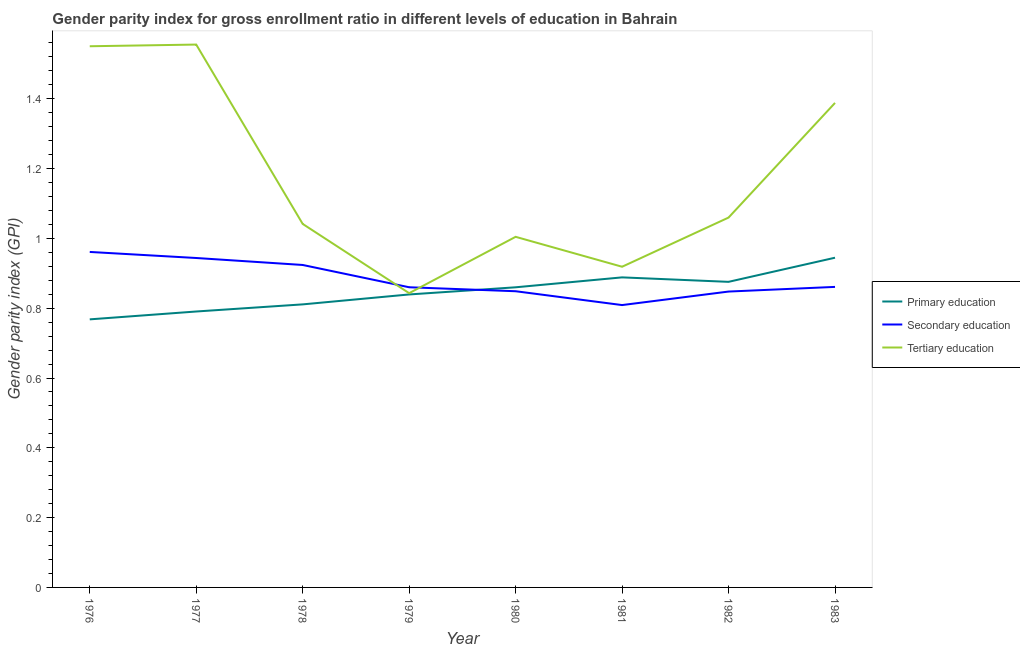How many different coloured lines are there?
Offer a terse response. 3. What is the gender parity index in secondary education in 1979?
Give a very brief answer. 0.86. Across all years, what is the maximum gender parity index in primary education?
Provide a short and direct response. 0.94. Across all years, what is the minimum gender parity index in primary education?
Offer a very short reply. 0.77. In which year was the gender parity index in primary education minimum?
Your response must be concise. 1976. What is the total gender parity index in primary education in the graph?
Provide a short and direct response. 6.78. What is the difference between the gender parity index in secondary education in 1978 and that in 1983?
Keep it short and to the point. 0.06. What is the difference between the gender parity index in primary education in 1980 and the gender parity index in tertiary education in 1978?
Your answer should be compact. -0.18. What is the average gender parity index in secondary education per year?
Make the answer very short. 0.88. In the year 1978, what is the difference between the gender parity index in secondary education and gender parity index in primary education?
Make the answer very short. 0.11. What is the ratio of the gender parity index in primary education in 1977 to that in 1982?
Offer a terse response. 0.9. Is the gender parity index in tertiary education in 1978 less than that in 1983?
Make the answer very short. Yes. What is the difference between the highest and the second highest gender parity index in secondary education?
Give a very brief answer. 0.02. What is the difference between the highest and the lowest gender parity index in primary education?
Make the answer very short. 0.18. In how many years, is the gender parity index in tertiary education greater than the average gender parity index in tertiary education taken over all years?
Keep it short and to the point. 3. How many lines are there?
Your answer should be very brief. 3. What is the difference between two consecutive major ticks on the Y-axis?
Your answer should be compact. 0.2. Does the graph contain any zero values?
Offer a very short reply. No. How are the legend labels stacked?
Your answer should be very brief. Vertical. What is the title of the graph?
Offer a terse response. Gender parity index for gross enrollment ratio in different levels of education in Bahrain. Does "Grants" appear as one of the legend labels in the graph?
Your answer should be very brief. No. What is the label or title of the X-axis?
Make the answer very short. Year. What is the label or title of the Y-axis?
Ensure brevity in your answer.  Gender parity index (GPI). What is the Gender parity index (GPI) in Primary education in 1976?
Your answer should be very brief. 0.77. What is the Gender parity index (GPI) of Secondary education in 1976?
Make the answer very short. 0.96. What is the Gender parity index (GPI) of Tertiary education in 1976?
Keep it short and to the point. 1.55. What is the Gender parity index (GPI) in Primary education in 1977?
Your response must be concise. 0.79. What is the Gender parity index (GPI) in Secondary education in 1977?
Offer a very short reply. 0.94. What is the Gender parity index (GPI) in Tertiary education in 1977?
Offer a very short reply. 1.56. What is the Gender parity index (GPI) in Primary education in 1978?
Ensure brevity in your answer.  0.81. What is the Gender parity index (GPI) of Secondary education in 1978?
Give a very brief answer. 0.92. What is the Gender parity index (GPI) in Tertiary education in 1978?
Your answer should be compact. 1.04. What is the Gender parity index (GPI) in Primary education in 1979?
Give a very brief answer. 0.84. What is the Gender parity index (GPI) of Secondary education in 1979?
Your answer should be compact. 0.86. What is the Gender parity index (GPI) in Tertiary education in 1979?
Make the answer very short. 0.84. What is the Gender parity index (GPI) in Primary education in 1980?
Offer a very short reply. 0.86. What is the Gender parity index (GPI) in Secondary education in 1980?
Offer a very short reply. 0.85. What is the Gender parity index (GPI) of Tertiary education in 1980?
Your answer should be very brief. 1. What is the Gender parity index (GPI) in Primary education in 1981?
Offer a terse response. 0.89. What is the Gender parity index (GPI) in Secondary education in 1981?
Your answer should be compact. 0.81. What is the Gender parity index (GPI) in Tertiary education in 1981?
Your answer should be compact. 0.92. What is the Gender parity index (GPI) of Primary education in 1982?
Provide a succinct answer. 0.88. What is the Gender parity index (GPI) of Secondary education in 1982?
Make the answer very short. 0.85. What is the Gender parity index (GPI) in Tertiary education in 1982?
Your response must be concise. 1.06. What is the Gender parity index (GPI) in Primary education in 1983?
Your answer should be very brief. 0.94. What is the Gender parity index (GPI) of Secondary education in 1983?
Make the answer very short. 0.86. What is the Gender parity index (GPI) in Tertiary education in 1983?
Ensure brevity in your answer.  1.39. Across all years, what is the maximum Gender parity index (GPI) of Primary education?
Keep it short and to the point. 0.94. Across all years, what is the maximum Gender parity index (GPI) of Secondary education?
Your answer should be compact. 0.96. Across all years, what is the maximum Gender parity index (GPI) in Tertiary education?
Offer a very short reply. 1.56. Across all years, what is the minimum Gender parity index (GPI) of Primary education?
Keep it short and to the point. 0.77. Across all years, what is the minimum Gender parity index (GPI) of Secondary education?
Offer a terse response. 0.81. Across all years, what is the minimum Gender parity index (GPI) in Tertiary education?
Provide a succinct answer. 0.84. What is the total Gender parity index (GPI) in Primary education in the graph?
Provide a succinct answer. 6.78. What is the total Gender parity index (GPI) of Secondary education in the graph?
Your answer should be very brief. 7.06. What is the total Gender parity index (GPI) of Tertiary education in the graph?
Offer a very short reply. 9.36. What is the difference between the Gender parity index (GPI) in Primary education in 1976 and that in 1977?
Make the answer very short. -0.02. What is the difference between the Gender parity index (GPI) of Secondary education in 1976 and that in 1977?
Ensure brevity in your answer.  0.02. What is the difference between the Gender parity index (GPI) in Tertiary education in 1976 and that in 1977?
Provide a succinct answer. -0. What is the difference between the Gender parity index (GPI) of Primary education in 1976 and that in 1978?
Provide a short and direct response. -0.04. What is the difference between the Gender parity index (GPI) in Secondary education in 1976 and that in 1978?
Ensure brevity in your answer.  0.04. What is the difference between the Gender parity index (GPI) in Tertiary education in 1976 and that in 1978?
Offer a very short reply. 0.51. What is the difference between the Gender parity index (GPI) of Primary education in 1976 and that in 1979?
Make the answer very short. -0.07. What is the difference between the Gender parity index (GPI) in Secondary education in 1976 and that in 1979?
Keep it short and to the point. 0.1. What is the difference between the Gender parity index (GPI) of Tertiary education in 1976 and that in 1979?
Your answer should be compact. 0.71. What is the difference between the Gender parity index (GPI) in Primary education in 1976 and that in 1980?
Make the answer very short. -0.09. What is the difference between the Gender parity index (GPI) in Secondary education in 1976 and that in 1980?
Make the answer very short. 0.11. What is the difference between the Gender parity index (GPI) of Tertiary education in 1976 and that in 1980?
Keep it short and to the point. 0.55. What is the difference between the Gender parity index (GPI) in Primary education in 1976 and that in 1981?
Your answer should be very brief. -0.12. What is the difference between the Gender parity index (GPI) of Secondary education in 1976 and that in 1981?
Your answer should be compact. 0.15. What is the difference between the Gender parity index (GPI) in Tertiary education in 1976 and that in 1981?
Your answer should be very brief. 0.63. What is the difference between the Gender parity index (GPI) of Primary education in 1976 and that in 1982?
Your response must be concise. -0.11. What is the difference between the Gender parity index (GPI) of Secondary education in 1976 and that in 1982?
Give a very brief answer. 0.11. What is the difference between the Gender parity index (GPI) in Tertiary education in 1976 and that in 1982?
Give a very brief answer. 0.49. What is the difference between the Gender parity index (GPI) in Primary education in 1976 and that in 1983?
Ensure brevity in your answer.  -0.18. What is the difference between the Gender parity index (GPI) of Secondary education in 1976 and that in 1983?
Provide a short and direct response. 0.1. What is the difference between the Gender parity index (GPI) of Tertiary education in 1976 and that in 1983?
Ensure brevity in your answer.  0.16. What is the difference between the Gender parity index (GPI) of Primary education in 1977 and that in 1978?
Give a very brief answer. -0.02. What is the difference between the Gender parity index (GPI) of Tertiary education in 1977 and that in 1978?
Offer a very short reply. 0.51. What is the difference between the Gender parity index (GPI) of Primary education in 1977 and that in 1979?
Make the answer very short. -0.05. What is the difference between the Gender parity index (GPI) of Secondary education in 1977 and that in 1979?
Your answer should be compact. 0.08. What is the difference between the Gender parity index (GPI) of Tertiary education in 1977 and that in 1979?
Offer a terse response. 0.71. What is the difference between the Gender parity index (GPI) in Primary education in 1977 and that in 1980?
Make the answer very short. -0.07. What is the difference between the Gender parity index (GPI) in Secondary education in 1977 and that in 1980?
Make the answer very short. 0.1. What is the difference between the Gender parity index (GPI) of Tertiary education in 1977 and that in 1980?
Ensure brevity in your answer.  0.55. What is the difference between the Gender parity index (GPI) of Primary education in 1977 and that in 1981?
Offer a very short reply. -0.1. What is the difference between the Gender parity index (GPI) of Secondary education in 1977 and that in 1981?
Offer a terse response. 0.13. What is the difference between the Gender parity index (GPI) of Tertiary education in 1977 and that in 1981?
Ensure brevity in your answer.  0.64. What is the difference between the Gender parity index (GPI) in Primary education in 1977 and that in 1982?
Your answer should be very brief. -0.09. What is the difference between the Gender parity index (GPI) in Secondary education in 1977 and that in 1982?
Ensure brevity in your answer.  0.1. What is the difference between the Gender parity index (GPI) in Tertiary education in 1977 and that in 1982?
Provide a short and direct response. 0.5. What is the difference between the Gender parity index (GPI) in Primary education in 1977 and that in 1983?
Make the answer very short. -0.15. What is the difference between the Gender parity index (GPI) of Secondary education in 1977 and that in 1983?
Make the answer very short. 0.08. What is the difference between the Gender parity index (GPI) of Tertiary education in 1977 and that in 1983?
Keep it short and to the point. 0.17. What is the difference between the Gender parity index (GPI) in Primary education in 1978 and that in 1979?
Your answer should be very brief. -0.03. What is the difference between the Gender parity index (GPI) in Secondary education in 1978 and that in 1979?
Ensure brevity in your answer.  0.06. What is the difference between the Gender parity index (GPI) in Tertiary education in 1978 and that in 1979?
Make the answer very short. 0.2. What is the difference between the Gender parity index (GPI) of Primary education in 1978 and that in 1980?
Your answer should be very brief. -0.05. What is the difference between the Gender parity index (GPI) in Secondary education in 1978 and that in 1980?
Offer a terse response. 0.08. What is the difference between the Gender parity index (GPI) in Tertiary education in 1978 and that in 1980?
Offer a very short reply. 0.04. What is the difference between the Gender parity index (GPI) of Primary education in 1978 and that in 1981?
Offer a terse response. -0.08. What is the difference between the Gender parity index (GPI) in Secondary education in 1978 and that in 1981?
Give a very brief answer. 0.11. What is the difference between the Gender parity index (GPI) in Tertiary education in 1978 and that in 1981?
Offer a very short reply. 0.12. What is the difference between the Gender parity index (GPI) in Primary education in 1978 and that in 1982?
Your response must be concise. -0.06. What is the difference between the Gender parity index (GPI) of Secondary education in 1978 and that in 1982?
Provide a succinct answer. 0.08. What is the difference between the Gender parity index (GPI) in Tertiary education in 1978 and that in 1982?
Provide a succinct answer. -0.02. What is the difference between the Gender parity index (GPI) of Primary education in 1978 and that in 1983?
Make the answer very short. -0.13. What is the difference between the Gender parity index (GPI) in Secondary education in 1978 and that in 1983?
Give a very brief answer. 0.06. What is the difference between the Gender parity index (GPI) in Tertiary education in 1978 and that in 1983?
Your response must be concise. -0.35. What is the difference between the Gender parity index (GPI) of Primary education in 1979 and that in 1980?
Offer a terse response. -0.02. What is the difference between the Gender parity index (GPI) of Secondary education in 1979 and that in 1980?
Provide a short and direct response. 0.01. What is the difference between the Gender parity index (GPI) of Tertiary education in 1979 and that in 1980?
Your answer should be compact. -0.16. What is the difference between the Gender parity index (GPI) of Primary education in 1979 and that in 1981?
Ensure brevity in your answer.  -0.05. What is the difference between the Gender parity index (GPI) of Secondary education in 1979 and that in 1981?
Ensure brevity in your answer.  0.05. What is the difference between the Gender parity index (GPI) in Tertiary education in 1979 and that in 1981?
Make the answer very short. -0.08. What is the difference between the Gender parity index (GPI) in Primary education in 1979 and that in 1982?
Provide a short and direct response. -0.04. What is the difference between the Gender parity index (GPI) of Secondary education in 1979 and that in 1982?
Ensure brevity in your answer.  0.01. What is the difference between the Gender parity index (GPI) in Tertiary education in 1979 and that in 1982?
Keep it short and to the point. -0.22. What is the difference between the Gender parity index (GPI) in Primary education in 1979 and that in 1983?
Offer a very short reply. -0.11. What is the difference between the Gender parity index (GPI) of Secondary education in 1979 and that in 1983?
Provide a short and direct response. -0. What is the difference between the Gender parity index (GPI) in Tertiary education in 1979 and that in 1983?
Keep it short and to the point. -0.55. What is the difference between the Gender parity index (GPI) in Primary education in 1980 and that in 1981?
Provide a succinct answer. -0.03. What is the difference between the Gender parity index (GPI) of Secondary education in 1980 and that in 1981?
Your answer should be compact. 0.04. What is the difference between the Gender parity index (GPI) in Tertiary education in 1980 and that in 1981?
Provide a short and direct response. 0.09. What is the difference between the Gender parity index (GPI) of Primary education in 1980 and that in 1982?
Your response must be concise. -0.02. What is the difference between the Gender parity index (GPI) in Secondary education in 1980 and that in 1982?
Ensure brevity in your answer.  0. What is the difference between the Gender parity index (GPI) of Tertiary education in 1980 and that in 1982?
Provide a short and direct response. -0.06. What is the difference between the Gender parity index (GPI) in Primary education in 1980 and that in 1983?
Your answer should be very brief. -0.08. What is the difference between the Gender parity index (GPI) of Secondary education in 1980 and that in 1983?
Offer a terse response. -0.01. What is the difference between the Gender parity index (GPI) in Tertiary education in 1980 and that in 1983?
Your answer should be compact. -0.38. What is the difference between the Gender parity index (GPI) in Primary education in 1981 and that in 1982?
Give a very brief answer. 0.01. What is the difference between the Gender parity index (GPI) in Secondary education in 1981 and that in 1982?
Give a very brief answer. -0.04. What is the difference between the Gender parity index (GPI) of Tertiary education in 1981 and that in 1982?
Your response must be concise. -0.14. What is the difference between the Gender parity index (GPI) of Primary education in 1981 and that in 1983?
Your response must be concise. -0.06. What is the difference between the Gender parity index (GPI) of Secondary education in 1981 and that in 1983?
Provide a short and direct response. -0.05. What is the difference between the Gender parity index (GPI) of Tertiary education in 1981 and that in 1983?
Offer a very short reply. -0.47. What is the difference between the Gender parity index (GPI) in Primary education in 1982 and that in 1983?
Your answer should be compact. -0.07. What is the difference between the Gender parity index (GPI) in Secondary education in 1982 and that in 1983?
Keep it short and to the point. -0.01. What is the difference between the Gender parity index (GPI) of Tertiary education in 1982 and that in 1983?
Make the answer very short. -0.33. What is the difference between the Gender parity index (GPI) in Primary education in 1976 and the Gender parity index (GPI) in Secondary education in 1977?
Provide a short and direct response. -0.18. What is the difference between the Gender parity index (GPI) of Primary education in 1976 and the Gender parity index (GPI) of Tertiary education in 1977?
Provide a short and direct response. -0.79. What is the difference between the Gender parity index (GPI) of Secondary education in 1976 and the Gender parity index (GPI) of Tertiary education in 1977?
Give a very brief answer. -0.59. What is the difference between the Gender parity index (GPI) in Primary education in 1976 and the Gender parity index (GPI) in Secondary education in 1978?
Provide a succinct answer. -0.16. What is the difference between the Gender parity index (GPI) of Primary education in 1976 and the Gender parity index (GPI) of Tertiary education in 1978?
Provide a succinct answer. -0.27. What is the difference between the Gender parity index (GPI) of Secondary education in 1976 and the Gender parity index (GPI) of Tertiary education in 1978?
Offer a very short reply. -0.08. What is the difference between the Gender parity index (GPI) of Primary education in 1976 and the Gender parity index (GPI) of Secondary education in 1979?
Provide a succinct answer. -0.09. What is the difference between the Gender parity index (GPI) in Primary education in 1976 and the Gender parity index (GPI) in Tertiary education in 1979?
Keep it short and to the point. -0.07. What is the difference between the Gender parity index (GPI) of Secondary education in 1976 and the Gender parity index (GPI) of Tertiary education in 1979?
Your response must be concise. 0.12. What is the difference between the Gender parity index (GPI) of Primary education in 1976 and the Gender parity index (GPI) of Secondary education in 1980?
Offer a very short reply. -0.08. What is the difference between the Gender parity index (GPI) of Primary education in 1976 and the Gender parity index (GPI) of Tertiary education in 1980?
Provide a succinct answer. -0.24. What is the difference between the Gender parity index (GPI) of Secondary education in 1976 and the Gender parity index (GPI) of Tertiary education in 1980?
Your response must be concise. -0.04. What is the difference between the Gender parity index (GPI) in Primary education in 1976 and the Gender parity index (GPI) in Secondary education in 1981?
Your response must be concise. -0.04. What is the difference between the Gender parity index (GPI) of Primary education in 1976 and the Gender parity index (GPI) of Tertiary education in 1981?
Provide a short and direct response. -0.15. What is the difference between the Gender parity index (GPI) in Secondary education in 1976 and the Gender parity index (GPI) in Tertiary education in 1981?
Offer a terse response. 0.04. What is the difference between the Gender parity index (GPI) in Primary education in 1976 and the Gender parity index (GPI) in Secondary education in 1982?
Your answer should be very brief. -0.08. What is the difference between the Gender parity index (GPI) in Primary education in 1976 and the Gender parity index (GPI) in Tertiary education in 1982?
Provide a succinct answer. -0.29. What is the difference between the Gender parity index (GPI) in Secondary education in 1976 and the Gender parity index (GPI) in Tertiary education in 1982?
Your answer should be very brief. -0.1. What is the difference between the Gender parity index (GPI) of Primary education in 1976 and the Gender parity index (GPI) of Secondary education in 1983?
Your answer should be very brief. -0.09. What is the difference between the Gender parity index (GPI) in Primary education in 1976 and the Gender parity index (GPI) in Tertiary education in 1983?
Offer a very short reply. -0.62. What is the difference between the Gender parity index (GPI) in Secondary education in 1976 and the Gender parity index (GPI) in Tertiary education in 1983?
Your answer should be compact. -0.43. What is the difference between the Gender parity index (GPI) of Primary education in 1977 and the Gender parity index (GPI) of Secondary education in 1978?
Provide a succinct answer. -0.13. What is the difference between the Gender parity index (GPI) in Primary education in 1977 and the Gender parity index (GPI) in Tertiary education in 1978?
Provide a succinct answer. -0.25. What is the difference between the Gender parity index (GPI) of Secondary education in 1977 and the Gender parity index (GPI) of Tertiary education in 1978?
Provide a short and direct response. -0.1. What is the difference between the Gender parity index (GPI) in Primary education in 1977 and the Gender parity index (GPI) in Secondary education in 1979?
Your response must be concise. -0.07. What is the difference between the Gender parity index (GPI) in Primary education in 1977 and the Gender parity index (GPI) in Tertiary education in 1979?
Keep it short and to the point. -0.05. What is the difference between the Gender parity index (GPI) of Secondary education in 1977 and the Gender parity index (GPI) of Tertiary education in 1979?
Make the answer very short. 0.1. What is the difference between the Gender parity index (GPI) of Primary education in 1977 and the Gender parity index (GPI) of Secondary education in 1980?
Ensure brevity in your answer.  -0.06. What is the difference between the Gender parity index (GPI) of Primary education in 1977 and the Gender parity index (GPI) of Tertiary education in 1980?
Offer a terse response. -0.21. What is the difference between the Gender parity index (GPI) of Secondary education in 1977 and the Gender parity index (GPI) of Tertiary education in 1980?
Provide a succinct answer. -0.06. What is the difference between the Gender parity index (GPI) in Primary education in 1977 and the Gender parity index (GPI) in Secondary education in 1981?
Provide a succinct answer. -0.02. What is the difference between the Gender parity index (GPI) in Primary education in 1977 and the Gender parity index (GPI) in Tertiary education in 1981?
Provide a succinct answer. -0.13. What is the difference between the Gender parity index (GPI) in Secondary education in 1977 and the Gender parity index (GPI) in Tertiary education in 1981?
Give a very brief answer. 0.03. What is the difference between the Gender parity index (GPI) in Primary education in 1977 and the Gender parity index (GPI) in Secondary education in 1982?
Give a very brief answer. -0.06. What is the difference between the Gender parity index (GPI) in Primary education in 1977 and the Gender parity index (GPI) in Tertiary education in 1982?
Your answer should be very brief. -0.27. What is the difference between the Gender parity index (GPI) of Secondary education in 1977 and the Gender parity index (GPI) of Tertiary education in 1982?
Your response must be concise. -0.12. What is the difference between the Gender parity index (GPI) in Primary education in 1977 and the Gender parity index (GPI) in Secondary education in 1983?
Your answer should be compact. -0.07. What is the difference between the Gender parity index (GPI) in Primary education in 1977 and the Gender parity index (GPI) in Tertiary education in 1983?
Offer a terse response. -0.6. What is the difference between the Gender parity index (GPI) of Secondary education in 1977 and the Gender parity index (GPI) of Tertiary education in 1983?
Make the answer very short. -0.44. What is the difference between the Gender parity index (GPI) in Primary education in 1978 and the Gender parity index (GPI) in Secondary education in 1979?
Your answer should be compact. -0.05. What is the difference between the Gender parity index (GPI) in Primary education in 1978 and the Gender parity index (GPI) in Tertiary education in 1979?
Offer a very short reply. -0.03. What is the difference between the Gender parity index (GPI) of Secondary education in 1978 and the Gender parity index (GPI) of Tertiary education in 1979?
Your answer should be compact. 0.08. What is the difference between the Gender parity index (GPI) of Primary education in 1978 and the Gender parity index (GPI) of Secondary education in 1980?
Your response must be concise. -0.04. What is the difference between the Gender parity index (GPI) of Primary education in 1978 and the Gender parity index (GPI) of Tertiary education in 1980?
Your response must be concise. -0.19. What is the difference between the Gender parity index (GPI) of Secondary education in 1978 and the Gender parity index (GPI) of Tertiary education in 1980?
Make the answer very short. -0.08. What is the difference between the Gender parity index (GPI) in Primary education in 1978 and the Gender parity index (GPI) in Secondary education in 1981?
Keep it short and to the point. 0. What is the difference between the Gender parity index (GPI) in Primary education in 1978 and the Gender parity index (GPI) in Tertiary education in 1981?
Your response must be concise. -0.11. What is the difference between the Gender parity index (GPI) of Secondary education in 1978 and the Gender parity index (GPI) of Tertiary education in 1981?
Offer a very short reply. 0.01. What is the difference between the Gender parity index (GPI) of Primary education in 1978 and the Gender parity index (GPI) of Secondary education in 1982?
Your response must be concise. -0.04. What is the difference between the Gender parity index (GPI) of Primary education in 1978 and the Gender parity index (GPI) of Tertiary education in 1982?
Give a very brief answer. -0.25. What is the difference between the Gender parity index (GPI) in Secondary education in 1978 and the Gender parity index (GPI) in Tertiary education in 1982?
Offer a terse response. -0.14. What is the difference between the Gender parity index (GPI) of Primary education in 1978 and the Gender parity index (GPI) of Secondary education in 1983?
Give a very brief answer. -0.05. What is the difference between the Gender parity index (GPI) in Primary education in 1978 and the Gender parity index (GPI) in Tertiary education in 1983?
Keep it short and to the point. -0.58. What is the difference between the Gender parity index (GPI) in Secondary education in 1978 and the Gender parity index (GPI) in Tertiary education in 1983?
Keep it short and to the point. -0.46. What is the difference between the Gender parity index (GPI) of Primary education in 1979 and the Gender parity index (GPI) of Secondary education in 1980?
Provide a short and direct response. -0.01. What is the difference between the Gender parity index (GPI) of Primary education in 1979 and the Gender parity index (GPI) of Tertiary education in 1980?
Keep it short and to the point. -0.17. What is the difference between the Gender parity index (GPI) in Secondary education in 1979 and the Gender parity index (GPI) in Tertiary education in 1980?
Ensure brevity in your answer.  -0.14. What is the difference between the Gender parity index (GPI) in Primary education in 1979 and the Gender parity index (GPI) in Secondary education in 1981?
Your answer should be compact. 0.03. What is the difference between the Gender parity index (GPI) of Primary education in 1979 and the Gender parity index (GPI) of Tertiary education in 1981?
Provide a succinct answer. -0.08. What is the difference between the Gender parity index (GPI) of Secondary education in 1979 and the Gender parity index (GPI) of Tertiary education in 1981?
Keep it short and to the point. -0.06. What is the difference between the Gender parity index (GPI) in Primary education in 1979 and the Gender parity index (GPI) in Secondary education in 1982?
Offer a terse response. -0.01. What is the difference between the Gender parity index (GPI) of Primary education in 1979 and the Gender parity index (GPI) of Tertiary education in 1982?
Offer a very short reply. -0.22. What is the difference between the Gender parity index (GPI) of Secondary education in 1979 and the Gender parity index (GPI) of Tertiary education in 1982?
Offer a very short reply. -0.2. What is the difference between the Gender parity index (GPI) of Primary education in 1979 and the Gender parity index (GPI) of Secondary education in 1983?
Give a very brief answer. -0.02. What is the difference between the Gender parity index (GPI) in Primary education in 1979 and the Gender parity index (GPI) in Tertiary education in 1983?
Your response must be concise. -0.55. What is the difference between the Gender parity index (GPI) of Secondary education in 1979 and the Gender parity index (GPI) of Tertiary education in 1983?
Make the answer very short. -0.53. What is the difference between the Gender parity index (GPI) of Primary education in 1980 and the Gender parity index (GPI) of Secondary education in 1981?
Your answer should be compact. 0.05. What is the difference between the Gender parity index (GPI) of Primary education in 1980 and the Gender parity index (GPI) of Tertiary education in 1981?
Your answer should be compact. -0.06. What is the difference between the Gender parity index (GPI) of Secondary education in 1980 and the Gender parity index (GPI) of Tertiary education in 1981?
Make the answer very short. -0.07. What is the difference between the Gender parity index (GPI) of Primary education in 1980 and the Gender parity index (GPI) of Secondary education in 1982?
Provide a short and direct response. 0.01. What is the difference between the Gender parity index (GPI) of Primary education in 1980 and the Gender parity index (GPI) of Tertiary education in 1982?
Offer a very short reply. -0.2. What is the difference between the Gender parity index (GPI) in Secondary education in 1980 and the Gender parity index (GPI) in Tertiary education in 1982?
Ensure brevity in your answer.  -0.21. What is the difference between the Gender parity index (GPI) of Primary education in 1980 and the Gender parity index (GPI) of Secondary education in 1983?
Provide a short and direct response. -0. What is the difference between the Gender parity index (GPI) in Primary education in 1980 and the Gender parity index (GPI) in Tertiary education in 1983?
Keep it short and to the point. -0.53. What is the difference between the Gender parity index (GPI) in Secondary education in 1980 and the Gender parity index (GPI) in Tertiary education in 1983?
Provide a succinct answer. -0.54. What is the difference between the Gender parity index (GPI) of Primary education in 1981 and the Gender parity index (GPI) of Secondary education in 1982?
Ensure brevity in your answer.  0.04. What is the difference between the Gender parity index (GPI) of Primary education in 1981 and the Gender parity index (GPI) of Tertiary education in 1982?
Your answer should be very brief. -0.17. What is the difference between the Gender parity index (GPI) of Secondary education in 1981 and the Gender parity index (GPI) of Tertiary education in 1982?
Provide a short and direct response. -0.25. What is the difference between the Gender parity index (GPI) in Primary education in 1981 and the Gender parity index (GPI) in Secondary education in 1983?
Your answer should be very brief. 0.03. What is the difference between the Gender parity index (GPI) in Primary education in 1981 and the Gender parity index (GPI) in Tertiary education in 1983?
Ensure brevity in your answer.  -0.5. What is the difference between the Gender parity index (GPI) in Secondary education in 1981 and the Gender parity index (GPI) in Tertiary education in 1983?
Give a very brief answer. -0.58. What is the difference between the Gender parity index (GPI) of Primary education in 1982 and the Gender parity index (GPI) of Secondary education in 1983?
Keep it short and to the point. 0.01. What is the difference between the Gender parity index (GPI) in Primary education in 1982 and the Gender parity index (GPI) in Tertiary education in 1983?
Your answer should be compact. -0.51. What is the difference between the Gender parity index (GPI) of Secondary education in 1982 and the Gender parity index (GPI) of Tertiary education in 1983?
Provide a short and direct response. -0.54. What is the average Gender parity index (GPI) in Primary education per year?
Make the answer very short. 0.85. What is the average Gender parity index (GPI) in Secondary education per year?
Your response must be concise. 0.88. What is the average Gender parity index (GPI) of Tertiary education per year?
Give a very brief answer. 1.17. In the year 1976, what is the difference between the Gender parity index (GPI) of Primary education and Gender parity index (GPI) of Secondary education?
Give a very brief answer. -0.19. In the year 1976, what is the difference between the Gender parity index (GPI) of Primary education and Gender parity index (GPI) of Tertiary education?
Provide a short and direct response. -0.78. In the year 1976, what is the difference between the Gender parity index (GPI) in Secondary education and Gender parity index (GPI) in Tertiary education?
Ensure brevity in your answer.  -0.59. In the year 1977, what is the difference between the Gender parity index (GPI) in Primary education and Gender parity index (GPI) in Secondary education?
Offer a very short reply. -0.15. In the year 1977, what is the difference between the Gender parity index (GPI) of Primary education and Gender parity index (GPI) of Tertiary education?
Provide a succinct answer. -0.76. In the year 1977, what is the difference between the Gender parity index (GPI) of Secondary education and Gender parity index (GPI) of Tertiary education?
Provide a short and direct response. -0.61. In the year 1978, what is the difference between the Gender parity index (GPI) in Primary education and Gender parity index (GPI) in Secondary education?
Offer a terse response. -0.11. In the year 1978, what is the difference between the Gender parity index (GPI) in Primary education and Gender parity index (GPI) in Tertiary education?
Keep it short and to the point. -0.23. In the year 1978, what is the difference between the Gender parity index (GPI) in Secondary education and Gender parity index (GPI) in Tertiary education?
Your answer should be very brief. -0.12. In the year 1979, what is the difference between the Gender parity index (GPI) of Primary education and Gender parity index (GPI) of Secondary education?
Provide a short and direct response. -0.02. In the year 1979, what is the difference between the Gender parity index (GPI) in Primary education and Gender parity index (GPI) in Tertiary education?
Offer a very short reply. -0. In the year 1979, what is the difference between the Gender parity index (GPI) of Secondary education and Gender parity index (GPI) of Tertiary education?
Provide a succinct answer. 0.02. In the year 1980, what is the difference between the Gender parity index (GPI) in Primary education and Gender parity index (GPI) in Secondary education?
Keep it short and to the point. 0.01. In the year 1980, what is the difference between the Gender parity index (GPI) of Primary education and Gender parity index (GPI) of Tertiary education?
Give a very brief answer. -0.14. In the year 1980, what is the difference between the Gender parity index (GPI) of Secondary education and Gender parity index (GPI) of Tertiary education?
Give a very brief answer. -0.16. In the year 1981, what is the difference between the Gender parity index (GPI) in Primary education and Gender parity index (GPI) in Secondary education?
Offer a terse response. 0.08. In the year 1981, what is the difference between the Gender parity index (GPI) of Primary education and Gender parity index (GPI) of Tertiary education?
Offer a terse response. -0.03. In the year 1981, what is the difference between the Gender parity index (GPI) in Secondary education and Gender parity index (GPI) in Tertiary education?
Make the answer very short. -0.11. In the year 1982, what is the difference between the Gender parity index (GPI) of Primary education and Gender parity index (GPI) of Secondary education?
Give a very brief answer. 0.03. In the year 1982, what is the difference between the Gender parity index (GPI) of Primary education and Gender parity index (GPI) of Tertiary education?
Your response must be concise. -0.18. In the year 1982, what is the difference between the Gender parity index (GPI) of Secondary education and Gender parity index (GPI) of Tertiary education?
Your answer should be very brief. -0.21. In the year 1983, what is the difference between the Gender parity index (GPI) in Primary education and Gender parity index (GPI) in Secondary education?
Keep it short and to the point. 0.08. In the year 1983, what is the difference between the Gender parity index (GPI) in Primary education and Gender parity index (GPI) in Tertiary education?
Your response must be concise. -0.44. In the year 1983, what is the difference between the Gender parity index (GPI) of Secondary education and Gender parity index (GPI) of Tertiary education?
Ensure brevity in your answer.  -0.53. What is the ratio of the Gender parity index (GPI) of Primary education in 1976 to that in 1977?
Provide a short and direct response. 0.97. What is the ratio of the Gender parity index (GPI) of Secondary education in 1976 to that in 1977?
Offer a terse response. 1.02. What is the ratio of the Gender parity index (GPI) of Tertiary education in 1976 to that in 1977?
Provide a succinct answer. 1. What is the ratio of the Gender parity index (GPI) in Primary education in 1976 to that in 1978?
Make the answer very short. 0.95. What is the ratio of the Gender parity index (GPI) in Secondary education in 1976 to that in 1978?
Make the answer very short. 1.04. What is the ratio of the Gender parity index (GPI) of Tertiary education in 1976 to that in 1978?
Offer a terse response. 1.49. What is the ratio of the Gender parity index (GPI) of Primary education in 1976 to that in 1979?
Offer a terse response. 0.92. What is the ratio of the Gender parity index (GPI) in Secondary education in 1976 to that in 1979?
Your answer should be very brief. 1.12. What is the ratio of the Gender parity index (GPI) of Tertiary education in 1976 to that in 1979?
Keep it short and to the point. 1.84. What is the ratio of the Gender parity index (GPI) in Primary education in 1976 to that in 1980?
Make the answer very short. 0.89. What is the ratio of the Gender parity index (GPI) in Secondary education in 1976 to that in 1980?
Keep it short and to the point. 1.13. What is the ratio of the Gender parity index (GPI) of Tertiary education in 1976 to that in 1980?
Your answer should be compact. 1.54. What is the ratio of the Gender parity index (GPI) in Primary education in 1976 to that in 1981?
Keep it short and to the point. 0.86. What is the ratio of the Gender parity index (GPI) of Secondary education in 1976 to that in 1981?
Offer a very short reply. 1.19. What is the ratio of the Gender parity index (GPI) of Tertiary education in 1976 to that in 1981?
Ensure brevity in your answer.  1.69. What is the ratio of the Gender parity index (GPI) of Primary education in 1976 to that in 1982?
Provide a succinct answer. 0.88. What is the ratio of the Gender parity index (GPI) in Secondary education in 1976 to that in 1982?
Offer a terse response. 1.13. What is the ratio of the Gender parity index (GPI) of Tertiary education in 1976 to that in 1982?
Offer a very short reply. 1.46. What is the ratio of the Gender parity index (GPI) in Primary education in 1976 to that in 1983?
Your answer should be compact. 0.81. What is the ratio of the Gender parity index (GPI) of Secondary education in 1976 to that in 1983?
Make the answer very short. 1.12. What is the ratio of the Gender parity index (GPI) of Tertiary education in 1976 to that in 1983?
Your answer should be very brief. 1.12. What is the ratio of the Gender parity index (GPI) in Primary education in 1977 to that in 1978?
Your answer should be very brief. 0.97. What is the ratio of the Gender parity index (GPI) in Secondary education in 1977 to that in 1978?
Provide a short and direct response. 1.02. What is the ratio of the Gender parity index (GPI) in Tertiary education in 1977 to that in 1978?
Provide a short and direct response. 1.49. What is the ratio of the Gender parity index (GPI) of Primary education in 1977 to that in 1979?
Make the answer very short. 0.94. What is the ratio of the Gender parity index (GPI) in Secondary education in 1977 to that in 1979?
Give a very brief answer. 1.1. What is the ratio of the Gender parity index (GPI) in Tertiary education in 1977 to that in 1979?
Your response must be concise. 1.84. What is the ratio of the Gender parity index (GPI) of Primary education in 1977 to that in 1980?
Ensure brevity in your answer.  0.92. What is the ratio of the Gender parity index (GPI) in Secondary education in 1977 to that in 1980?
Your answer should be compact. 1.11. What is the ratio of the Gender parity index (GPI) of Tertiary education in 1977 to that in 1980?
Make the answer very short. 1.55. What is the ratio of the Gender parity index (GPI) of Primary education in 1977 to that in 1981?
Ensure brevity in your answer.  0.89. What is the ratio of the Gender parity index (GPI) in Secondary education in 1977 to that in 1981?
Ensure brevity in your answer.  1.17. What is the ratio of the Gender parity index (GPI) of Tertiary education in 1977 to that in 1981?
Your answer should be compact. 1.69. What is the ratio of the Gender parity index (GPI) of Primary education in 1977 to that in 1982?
Offer a terse response. 0.9. What is the ratio of the Gender parity index (GPI) in Secondary education in 1977 to that in 1982?
Provide a short and direct response. 1.11. What is the ratio of the Gender parity index (GPI) of Tertiary education in 1977 to that in 1982?
Offer a terse response. 1.47. What is the ratio of the Gender parity index (GPI) of Primary education in 1977 to that in 1983?
Offer a terse response. 0.84. What is the ratio of the Gender parity index (GPI) of Secondary education in 1977 to that in 1983?
Offer a very short reply. 1.1. What is the ratio of the Gender parity index (GPI) in Tertiary education in 1977 to that in 1983?
Offer a terse response. 1.12. What is the ratio of the Gender parity index (GPI) of Primary education in 1978 to that in 1979?
Provide a short and direct response. 0.97. What is the ratio of the Gender parity index (GPI) of Secondary education in 1978 to that in 1979?
Your response must be concise. 1.07. What is the ratio of the Gender parity index (GPI) in Tertiary education in 1978 to that in 1979?
Your answer should be compact. 1.24. What is the ratio of the Gender parity index (GPI) of Primary education in 1978 to that in 1980?
Give a very brief answer. 0.94. What is the ratio of the Gender parity index (GPI) in Secondary education in 1978 to that in 1980?
Make the answer very short. 1.09. What is the ratio of the Gender parity index (GPI) in Tertiary education in 1978 to that in 1980?
Your response must be concise. 1.04. What is the ratio of the Gender parity index (GPI) of Primary education in 1978 to that in 1981?
Keep it short and to the point. 0.91. What is the ratio of the Gender parity index (GPI) of Secondary education in 1978 to that in 1981?
Your answer should be very brief. 1.14. What is the ratio of the Gender parity index (GPI) in Tertiary education in 1978 to that in 1981?
Make the answer very short. 1.13. What is the ratio of the Gender parity index (GPI) of Primary education in 1978 to that in 1982?
Your answer should be compact. 0.93. What is the ratio of the Gender parity index (GPI) in Secondary education in 1978 to that in 1982?
Ensure brevity in your answer.  1.09. What is the ratio of the Gender parity index (GPI) of Tertiary education in 1978 to that in 1982?
Your answer should be very brief. 0.98. What is the ratio of the Gender parity index (GPI) of Primary education in 1978 to that in 1983?
Provide a succinct answer. 0.86. What is the ratio of the Gender parity index (GPI) in Secondary education in 1978 to that in 1983?
Your answer should be very brief. 1.07. What is the ratio of the Gender parity index (GPI) of Tertiary education in 1978 to that in 1983?
Make the answer very short. 0.75. What is the ratio of the Gender parity index (GPI) of Primary education in 1979 to that in 1980?
Your answer should be very brief. 0.98. What is the ratio of the Gender parity index (GPI) of Secondary education in 1979 to that in 1980?
Keep it short and to the point. 1.01. What is the ratio of the Gender parity index (GPI) of Tertiary education in 1979 to that in 1980?
Provide a succinct answer. 0.84. What is the ratio of the Gender parity index (GPI) of Primary education in 1979 to that in 1981?
Your answer should be compact. 0.94. What is the ratio of the Gender parity index (GPI) of Secondary education in 1979 to that in 1981?
Keep it short and to the point. 1.06. What is the ratio of the Gender parity index (GPI) in Tertiary education in 1979 to that in 1981?
Ensure brevity in your answer.  0.92. What is the ratio of the Gender parity index (GPI) of Primary education in 1979 to that in 1982?
Give a very brief answer. 0.96. What is the ratio of the Gender parity index (GPI) of Secondary education in 1979 to that in 1982?
Keep it short and to the point. 1.01. What is the ratio of the Gender parity index (GPI) in Tertiary education in 1979 to that in 1982?
Your answer should be very brief. 0.8. What is the ratio of the Gender parity index (GPI) of Primary education in 1979 to that in 1983?
Ensure brevity in your answer.  0.89. What is the ratio of the Gender parity index (GPI) in Tertiary education in 1979 to that in 1983?
Offer a terse response. 0.61. What is the ratio of the Gender parity index (GPI) in Secondary education in 1980 to that in 1981?
Your answer should be compact. 1.05. What is the ratio of the Gender parity index (GPI) in Tertiary education in 1980 to that in 1981?
Your answer should be compact. 1.09. What is the ratio of the Gender parity index (GPI) of Primary education in 1980 to that in 1982?
Ensure brevity in your answer.  0.98. What is the ratio of the Gender parity index (GPI) in Tertiary education in 1980 to that in 1982?
Make the answer very short. 0.95. What is the ratio of the Gender parity index (GPI) in Primary education in 1980 to that in 1983?
Keep it short and to the point. 0.91. What is the ratio of the Gender parity index (GPI) of Secondary education in 1980 to that in 1983?
Give a very brief answer. 0.99. What is the ratio of the Gender parity index (GPI) in Tertiary education in 1980 to that in 1983?
Your answer should be compact. 0.72. What is the ratio of the Gender parity index (GPI) of Primary education in 1981 to that in 1982?
Keep it short and to the point. 1.01. What is the ratio of the Gender parity index (GPI) in Secondary education in 1981 to that in 1982?
Ensure brevity in your answer.  0.95. What is the ratio of the Gender parity index (GPI) of Tertiary education in 1981 to that in 1982?
Offer a very short reply. 0.87. What is the ratio of the Gender parity index (GPI) of Primary education in 1981 to that in 1983?
Provide a short and direct response. 0.94. What is the ratio of the Gender parity index (GPI) of Secondary education in 1981 to that in 1983?
Keep it short and to the point. 0.94. What is the ratio of the Gender parity index (GPI) of Tertiary education in 1981 to that in 1983?
Ensure brevity in your answer.  0.66. What is the ratio of the Gender parity index (GPI) in Primary education in 1982 to that in 1983?
Your response must be concise. 0.93. What is the ratio of the Gender parity index (GPI) of Secondary education in 1982 to that in 1983?
Keep it short and to the point. 0.98. What is the ratio of the Gender parity index (GPI) of Tertiary education in 1982 to that in 1983?
Your answer should be compact. 0.76. What is the difference between the highest and the second highest Gender parity index (GPI) of Primary education?
Make the answer very short. 0.06. What is the difference between the highest and the second highest Gender parity index (GPI) of Secondary education?
Provide a succinct answer. 0.02. What is the difference between the highest and the second highest Gender parity index (GPI) of Tertiary education?
Your response must be concise. 0. What is the difference between the highest and the lowest Gender parity index (GPI) of Primary education?
Ensure brevity in your answer.  0.18. What is the difference between the highest and the lowest Gender parity index (GPI) in Secondary education?
Ensure brevity in your answer.  0.15. What is the difference between the highest and the lowest Gender parity index (GPI) of Tertiary education?
Offer a terse response. 0.71. 